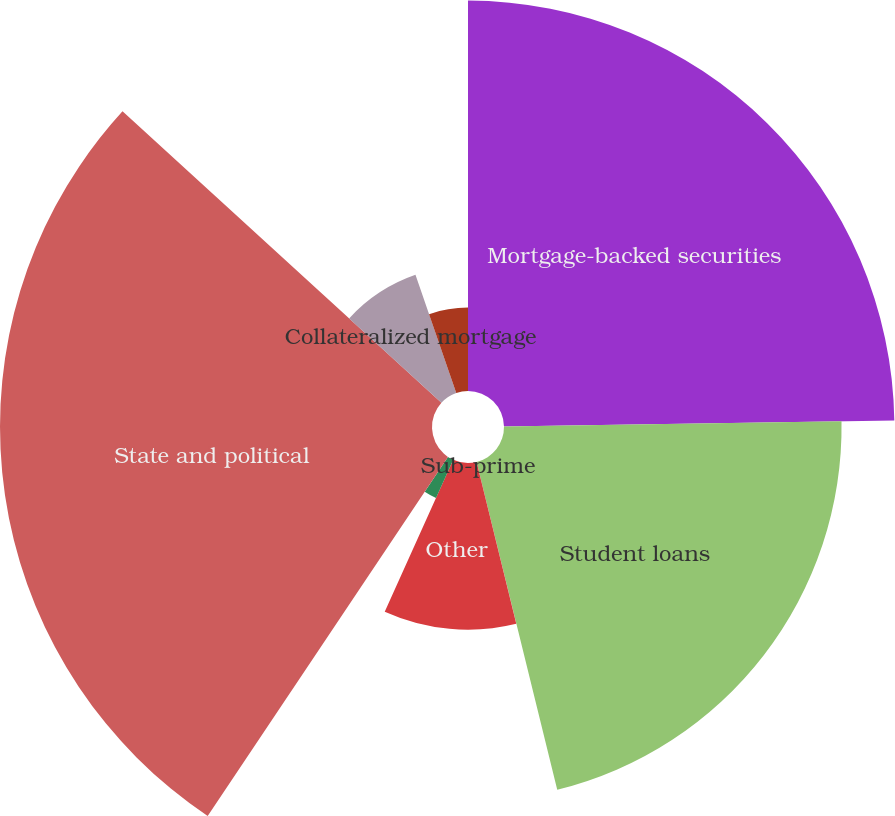Convert chart. <chart><loc_0><loc_0><loc_500><loc_500><pie_chart><fcel>Mortgage-backed securities<fcel>Student loans<fcel>Sub-prime<fcel>Other<fcel>Asset-backed securities<fcel>State and political<fcel>Collateralized mortgage<fcel>Other US debt securities<nl><fcel>24.76%<fcel>21.41%<fcel>0.01%<fcel>10.57%<fcel>2.65%<fcel>27.4%<fcel>7.93%<fcel>5.29%<nl></chart> 